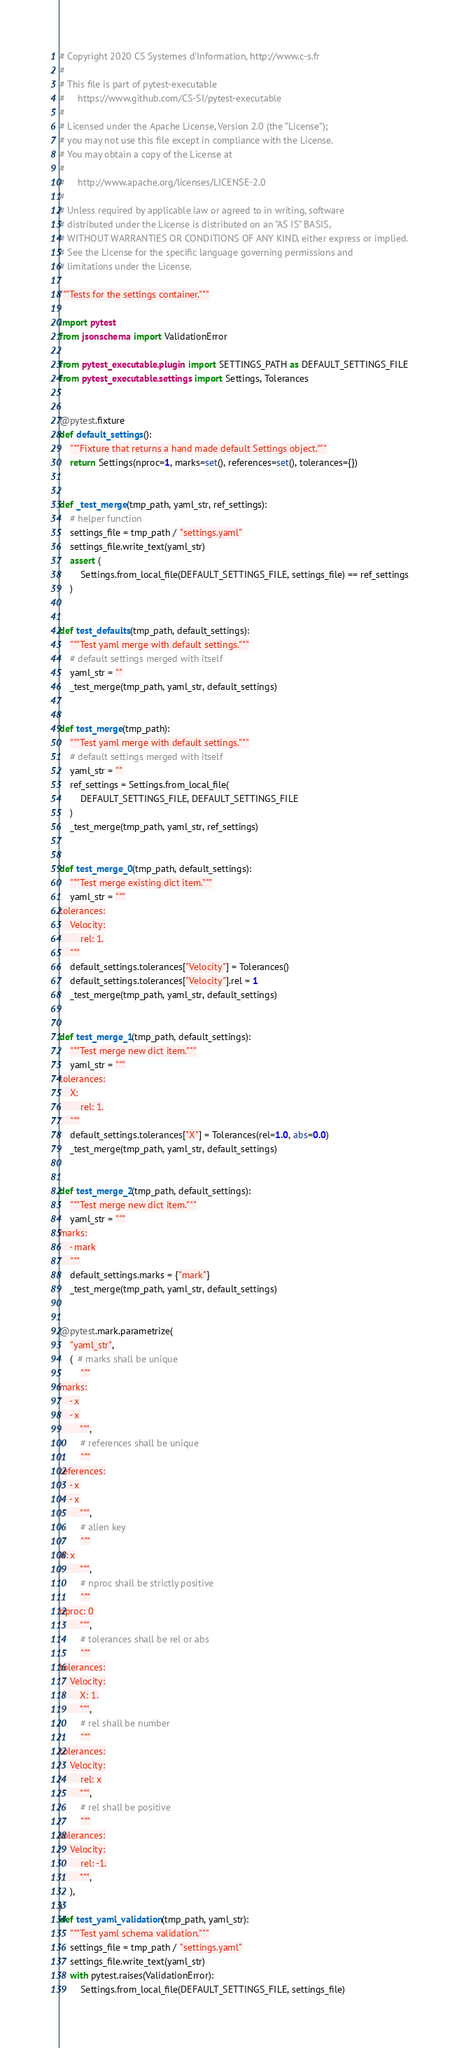Convert code to text. <code><loc_0><loc_0><loc_500><loc_500><_Python_># Copyright 2020 CS Systemes d'Information, http://www.c-s.fr
#
# This file is part of pytest-executable
#     https://www.github.com/CS-SI/pytest-executable
#
# Licensed under the Apache License, Version 2.0 (the "License");
# you may not use this file except in compliance with the License.
# You may obtain a copy of the License at
#
#     http://www.apache.org/licenses/LICENSE-2.0
#
# Unless required by applicable law or agreed to in writing, software
# distributed under the License is distributed on an "AS IS" BASIS,
# WITHOUT WARRANTIES OR CONDITIONS OF ANY KIND, either express or implied.
# See the License for the specific language governing permissions and
# limitations under the License.

"""Tests for the settings container."""

import pytest
from jsonschema import ValidationError

from pytest_executable.plugin import SETTINGS_PATH as DEFAULT_SETTINGS_FILE
from pytest_executable.settings import Settings, Tolerances


@pytest.fixture
def default_settings():
    """Fixture that returns a hand made default Settings object."""
    return Settings(nproc=1, marks=set(), references=set(), tolerances={})


def _test_merge(tmp_path, yaml_str, ref_settings):
    # helper function
    settings_file = tmp_path / "settings.yaml"
    settings_file.write_text(yaml_str)
    assert (
        Settings.from_local_file(DEFAULT_SETTINGS_FILE, settings_file) == ref_settings
    )


def test_defaults(tmp_path, default_settings):
    """Test yaml merge with default settings."""
    # default settings merged with itself
    yaml_str = ""
    _test_merge(tmp_path, yaml_str, default_settings)


def test_merge(tmp_path):
    """Test yaml merge with default settings."""
    # default settings merged with itself
    yaml_str = ""
    ref_settings = Settings.from_local_file(
        DEFAULT_SETTINGS_FILE, DEFAULT_SETTINGS_FILE
    )
    _test_merge(tmp_path, yaml_str, ref_settings)


def test_merge_0(tmp_path, default_settings):
    """Test merge existing dict item."""
    yaml_str = """
tolerances:
    Velocity:
        rel: 1.
    """
    default_settings.tolerances["Velocity"] = Tolerances()
    default_settings.tolerances["Velocity"].rel = 1
    _test_merge(tmp_path, yaml_str, default_settings)


def test_merge_1(tmp_path, default_settings):
    """Test merge new dict item."""
    yaml_str = """
tolerances:
    X:
        rel: 1.
    """
    default_settings.tolerances["X"] = Tolerances(rel=1.0, abs=0.0)
    _test_merge(tmp_path, yaml_str, default_settings)


def test_merge_2(tmp_path, default_settings):
    """Test merge new dict item."""
    yaml_str = """
marks:
    - mark
    """
    default_settings.marks = {"mark"}
    _test_merge(tmp_path, yaml_str, default_settings)


@pytest.mark.parametrize(
    "yaml_str",
    (  # marks shall be unique
        """
marks:
    - x
    - x
        """,
        # references shall be unique
        """
references:
    - x
    - x
        """,
        # alien key
        """
X: x
        """,
        # nproc shall be strictly positive
        """
nproc: 0
        """,
        # tolerances shall be rel or abs
        """
tolerances:
    Velocity:
        X: 1.
        """,
        # rel shall be number
        """
tolerances:
    Velocity:
        rel: x
        """,
        # rel shall be positive
        """
tolerances:
    Velocity:
        rel: -1.
        """,
    ),
)
def test_yaml_validation(tmp_path, yaml_str):
    """Test yaml schema validation."""
    settings_file = tmp_path / "settings.yaml"
    settings_file.write_text(yaml_str)
    with pytest.raises(ValidationError):
        Settings.from_local_file(DEFAULT_SETTINGS_FILE, settings_file)
</code> 